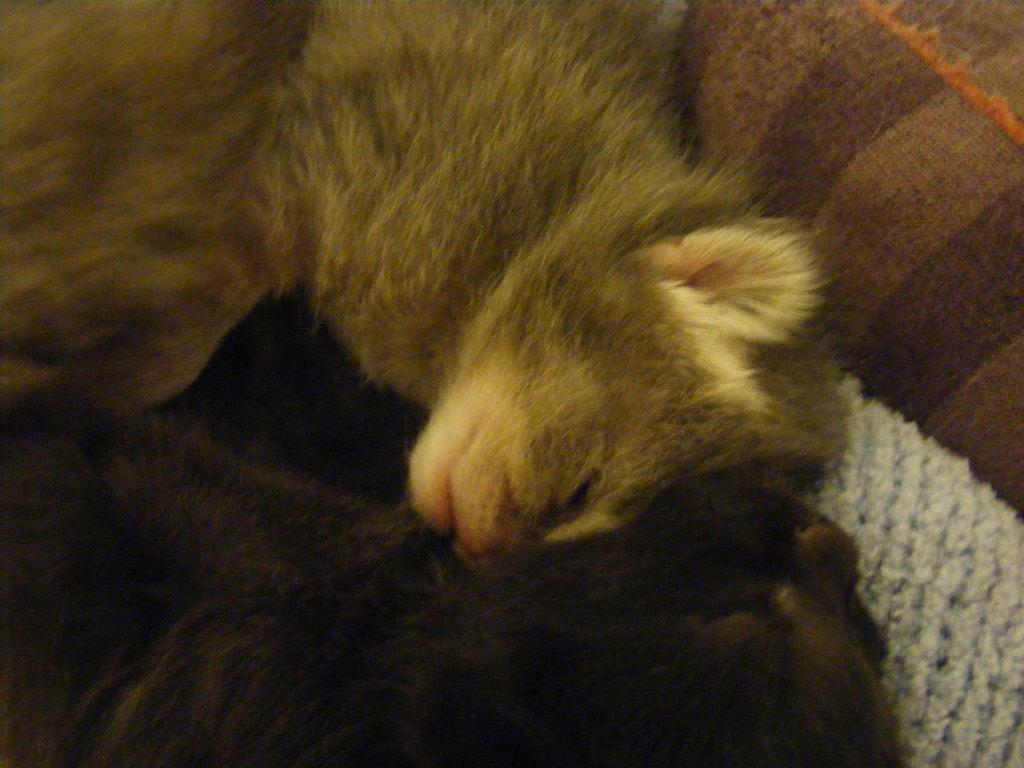What type of animal can be seen in the picture? There is a domestic animal in the picture. Where is the animal located in the image? The animal is sleeping on a sofa. What color is the woolen cloth in the picture? The woolen cloth in the picture is white in color. What is the color of the bottom part of the picture? The bottom part of the picture is black in color. Who is the owner of the match that is visible in the picture? There is no match present in the image, so it is not possible to determine the owner. 